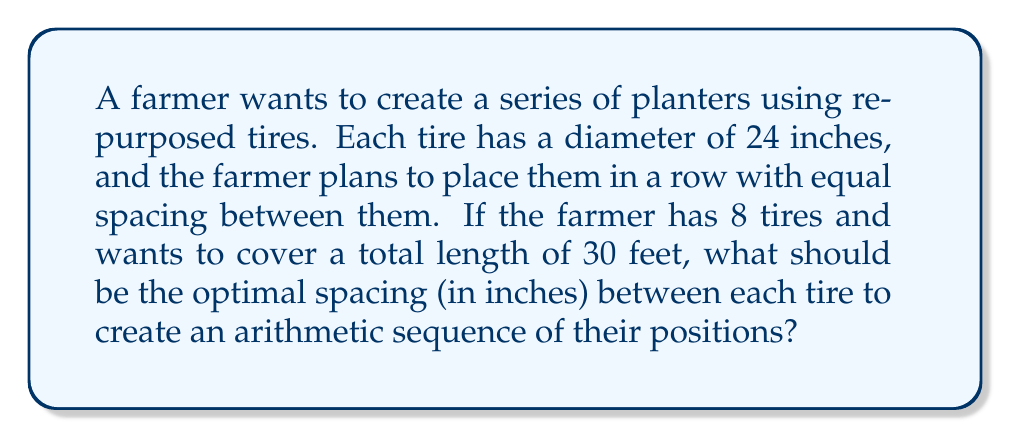Help me with this question. Let's approach this step-by-step:

1) First, let's convert all measurements to inches:
   30 feet = 30 * 12 = 360 inches

2) Let $d$ be the spacing between tires (in inches). We need to find $d$.

3) The total length covered will be:
   - Length of 8 tires: 8 * 24 = 192 inches
   - 7 spaces between tires: 7d inches
   
4) We can set up the equation:
   $$ 192 + 7d = 360 $$

5) Solving for $d$:
   $$ 7d = 360 - 192 = 168 $$
   $$ d = 168 / 7 = 24 $$

6) To verify this creates an arithmetic sequence, let's check the positions:
   - 1st tire center: 12 inches (half the diameter)
   - 2nd tire center: 12 + 24 + 24 = 60 inches
   - 3rd tire center: 60 + 24 + 24 = 108 inches
   ...and so on.

7) The sequence of positions is indeed arithmetic with a common difference of 48 inches.
Answer: 24 inches 